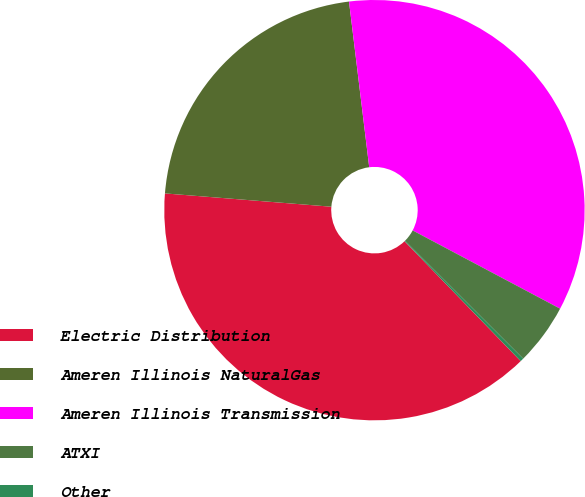<chart> <loc_0><loc_0><loc_500><loc_500><pie_chart><fcel>Electric Distribution<fcel>Ameren Illinois NaturalGas<fcel>Ameren Illinois Transmission<fcel>ATXI<fcel>Other<nl><fcel>38.52%<fcel>21.8%<fcel>34.7%<fcel>4.72%<fcel>0.27%<nl></chart> 